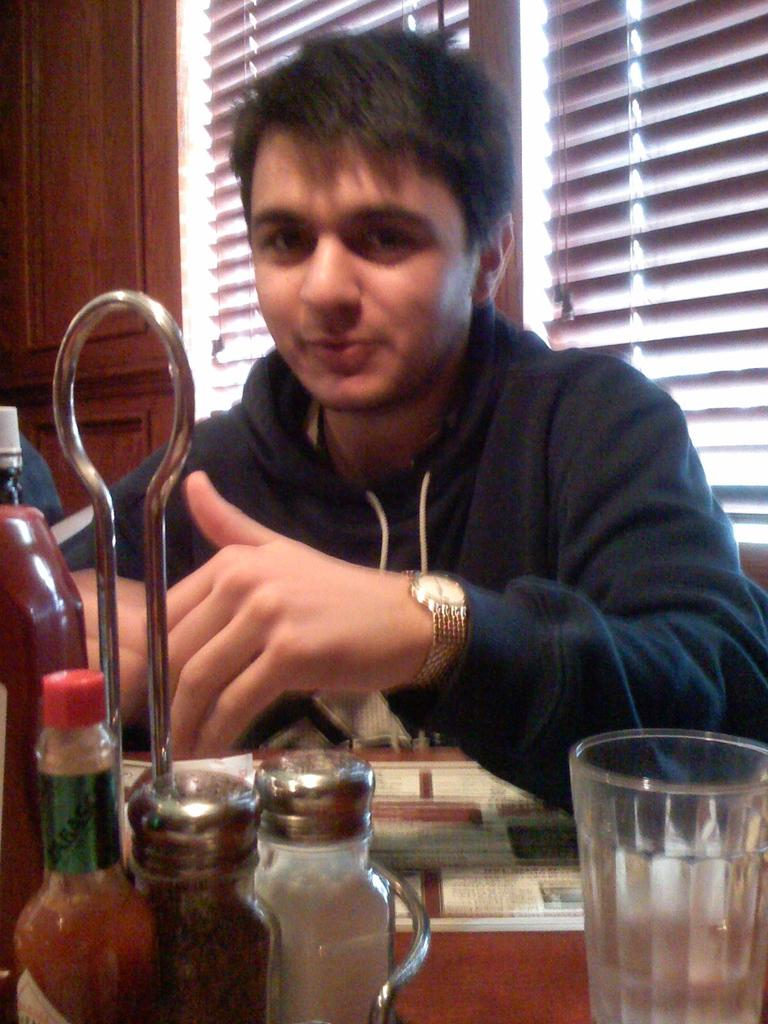Who is present in the image? There is a man in the image. What is the man wearing? The man is wearing a black t-shirt. What can be seen in front of the man? There are multiple objects in front of the man. What is visible in the background of the image? There is a window visible in the background of the image. How many dimes are arranged in a circle on the man's t-shirt in the image? There are no dimes or circles present on the man's t-shirt in the image. 